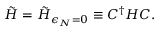<formula> <loc_0><loc_0><loc_500><loc_500>\tilde { H } = \tilde { H } _ { \epsilon _ { N } = 0 } \equiv C ^ { \dagger } H C .</formula> 